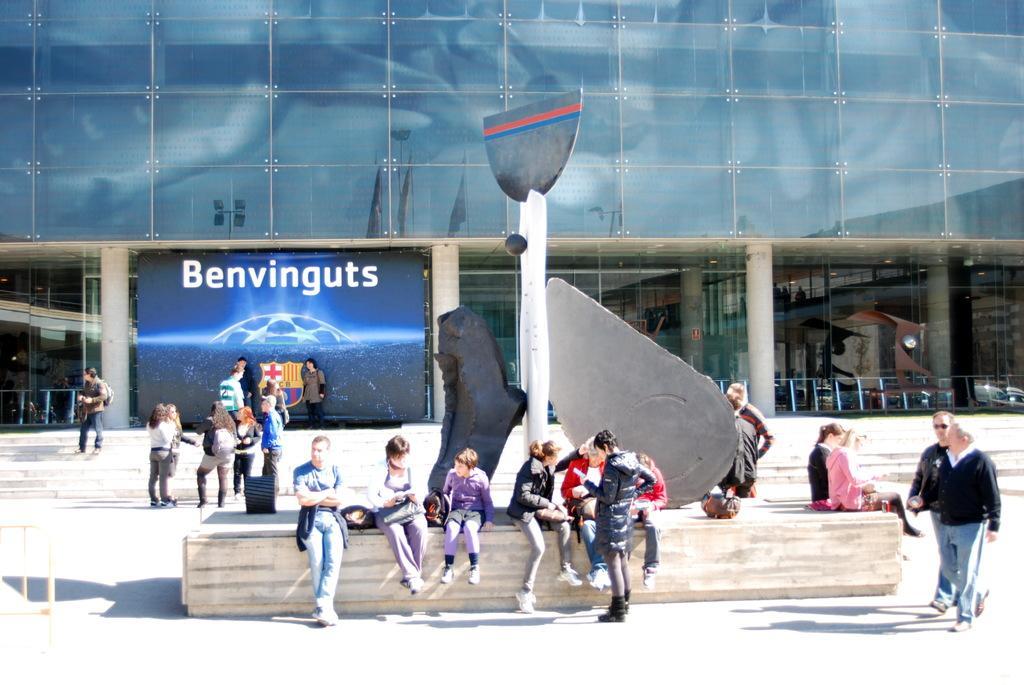Describe this image in one or two sentences. In this image in the front there are persons sitting and standing and walking. In the background there are steps and there are persons on the steps and there is a building and in front of the building there is a board which is blue in colour with some text written on it. 